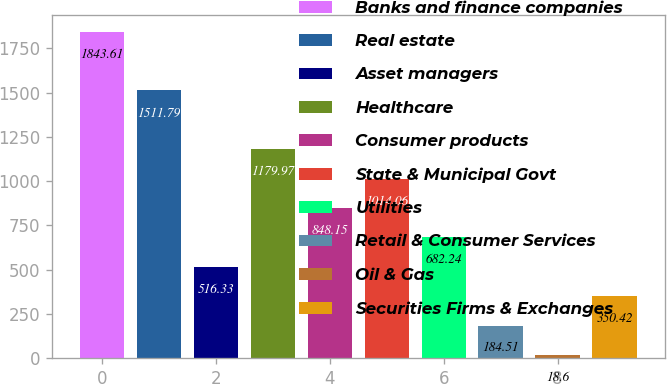<chart> <loc_0><loc_0><loc_500><loc_500><bar_chart><fcel>Banks and finance companies<fcel>Real estate<fcel>Asset managers<fcel>Healthcare<fcel>Consumer products<fcel>State & Municipal Govt<fcel>Utilities<fcel>Retail & Consumer Services<fcel>Oil & Gas<fcel>Securities Firms & Exchanges<nl><fcel>1843.61<fcel>1511.79<fcel>516.33<fcel>1179.97<fcel>848.15<fcel>1014.06<fcel>682.24<fcel>184.51<fcel>18.6<fcel>350.42<nl></chart> 